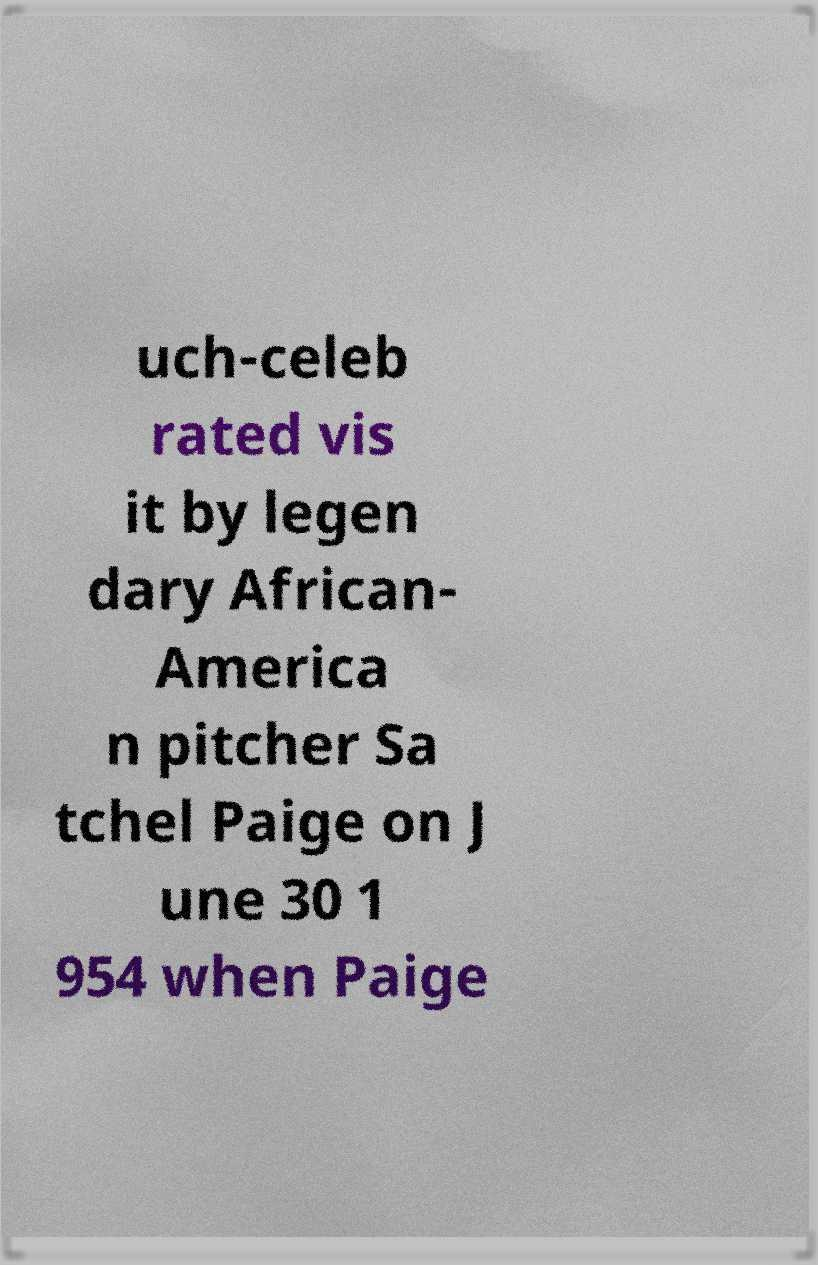Please read and relay the text visible in this image. What does it say? uch-celeb rated vis it by legen dary African- America n pitcher Sa tchel Paige on J une 30 1 954 when Paige 